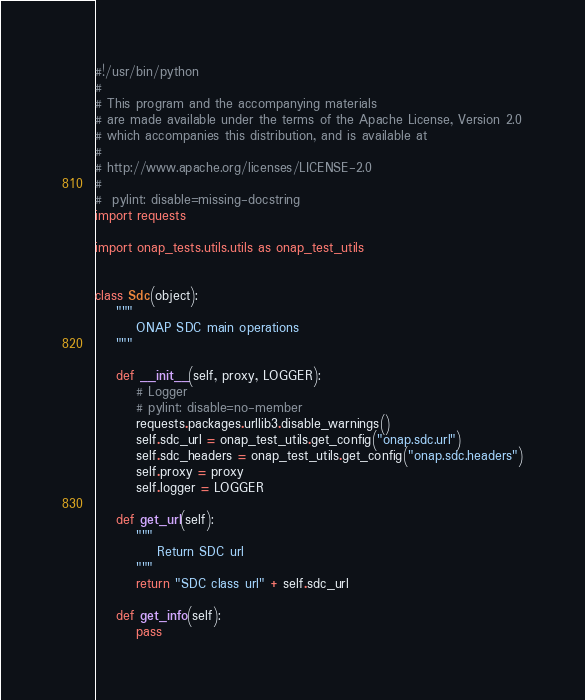<code> <loc_0><loc_0><loc_500><loc_500><_Python_>#!/usr/bin/python
#
# This program and the accompanying materials
# are made available under the terms of the Apache License, Version 2.0
# which accompanies this distribution, and is available at
#
# http://www.apache.org/licenses/LICENSE-2.0
#
#  pylint: disable=missing-docstring
import requests

import onap_tests.utils.utils as onap_test_utils


class Sdc(object):
    """
        ONAP SDC main operations
    """

    def __init__(self, proxy, LOGGER):
        # Logger
        # pylint: disable=no-member
        requests.packages.urllib3.disable_warnings()
        self.sdc_url = onap_test_utils.get_config("onap.sdc.url")
        self.sdc_headers = onap_test_utils.get_config("onap.sdc.headers")
        self.proxy = proxy
        self.logger = LOGGER

    def get_url(self):
        """
            Return SDC url
        """
        return "SDC class url" + self.sdc_url

    def get_info(self):
        pass
</code> 